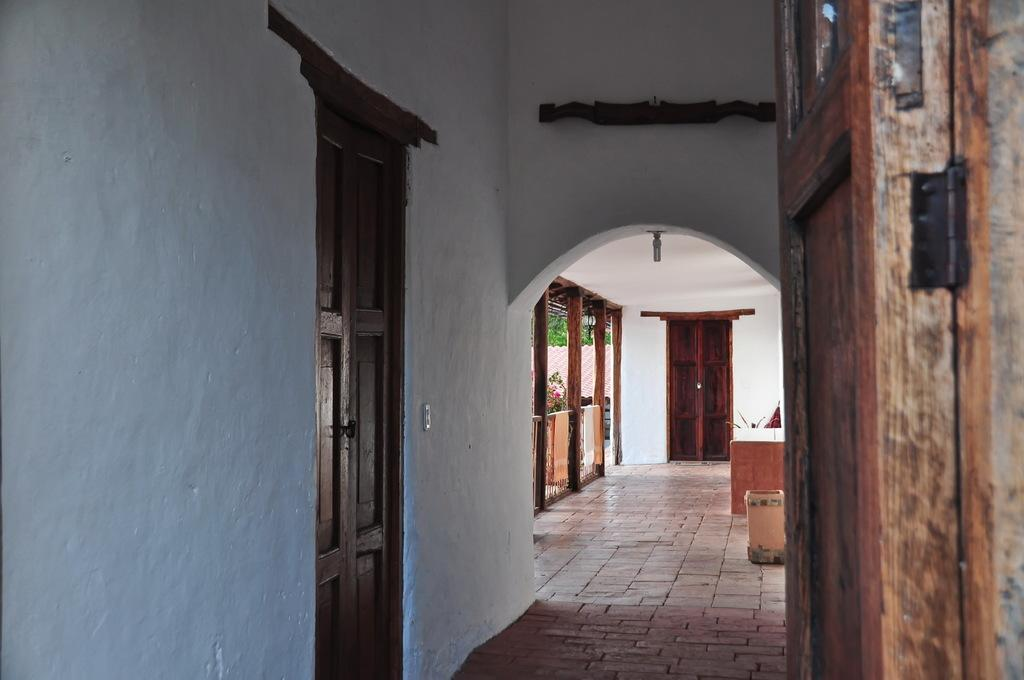What type of view does the image provide? The image shows the inner view of a building. What are some of the architectural features visible in the image? There are doors and walls visible in the image. What can be seen on the floor in the image? There are objects on the floor in the image. What is attached to the wall in the image? There is a wooden object attached to the wall in the image. Can you tell me how many birds are nesting in the image? There are no birds or nests present in the image. What type of reading material can be seen in the image? There is no reading material visible in the image. 